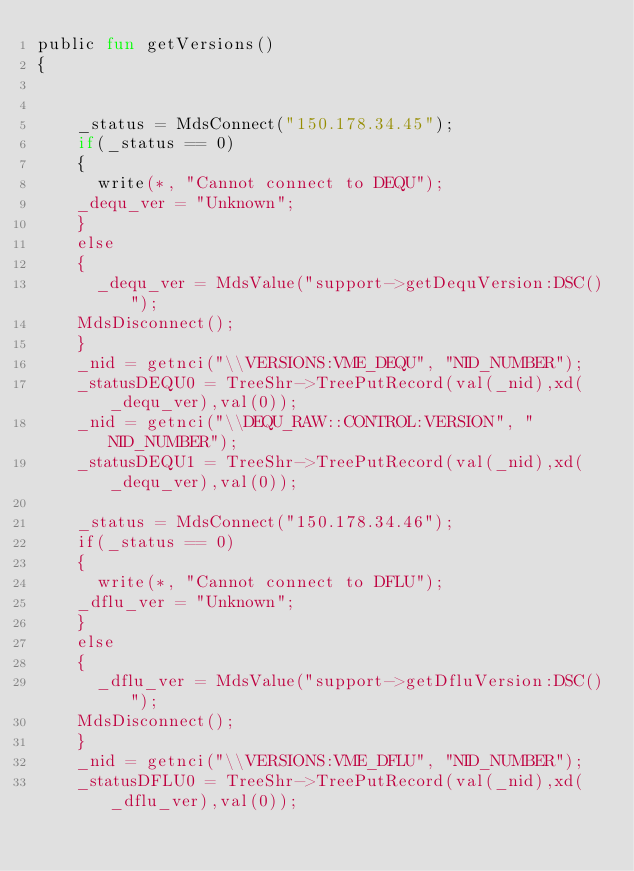<code> <loc_0><loc_0><loc_500><loc_500><_SML_>public fun getVersions()
{


    _status = MdsConnect("150.178.34.45");
    if(_status == 0)
    {
    	write(*, "Cannot connect to DEQU");
		_dequ_ver = "Unknown";
    }
    else
    {
    	_dequ_ver = MdsValue("support->getDequVersion:DSC()");
		MdsDisconnect();
    }
    _nid = getnci("\\VERSIONS:VME_DEQU", "NID_NUMBER");
    _statusDEQU0 = TreeShr->TreePutRecord(val(_nid),xd(_dequ_ver),val(0));
    _nid = getnci("\\DEQU_RAW::CONTROL:VERSION", "NID_NUMBER");
    _statusDEQU1 = TreeShr->TreePutRecord(val(_nid),xd(_dequ_ver),val(0));
	
    _status = MdsConnect("150.178.34.46");
    if(_status == 0)
    {
    	write(*, "Cannot connect to DFLU");
		_dflu_ver = "Unknown";
    }
    else
    {
    	_dflu_ver = MdsValue("support->getDfluVersion:DSC()");
		MdsDisconnect();
    }
    _nid = getnci("\\VERSIONS:VME_DFLU", "NID_NUMBER");
    _statusDFLU0 = TreeShr->TreePutRecord(val(_nid),xd(_dflu_ver),val(0));</code> 